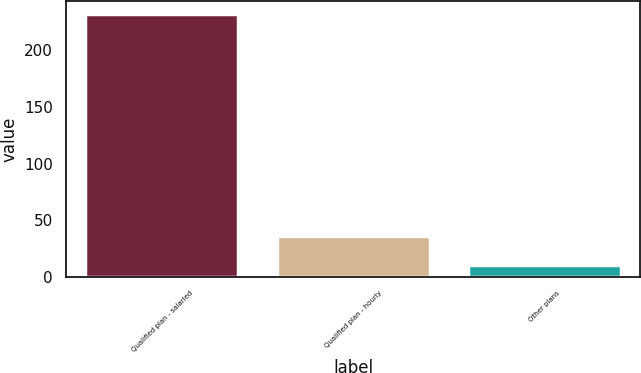Convert chart. <chart><loc_0><loc_0><loc_500><loc_500><bar_chart><fcel>Qualified plan - salaried<fcel>Qualified plan - hourly<fcel>Other plans<nl><fcel>232<fcel>36<fcel>10<nl></chart> 